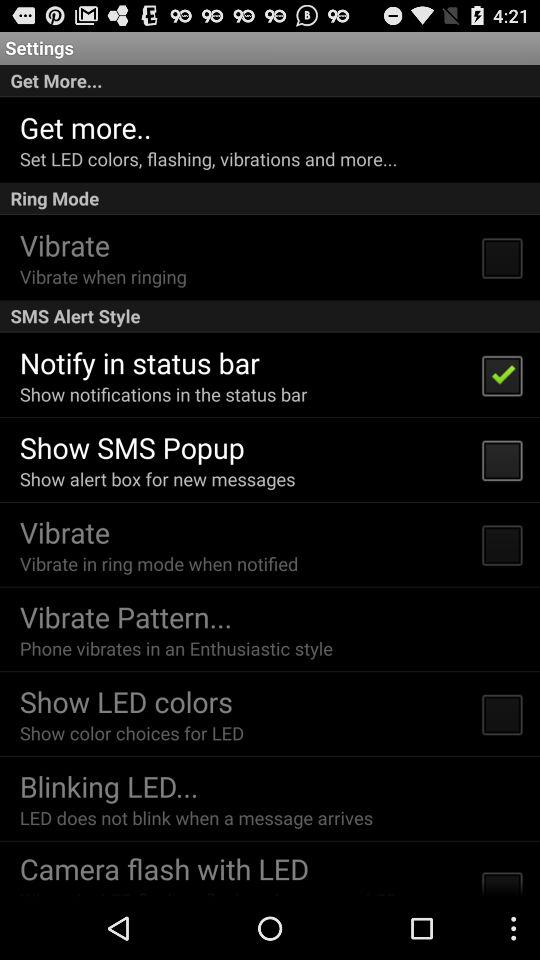What is the current status of "Show LED colors"? The current status of "Show LED colors" is "off". 